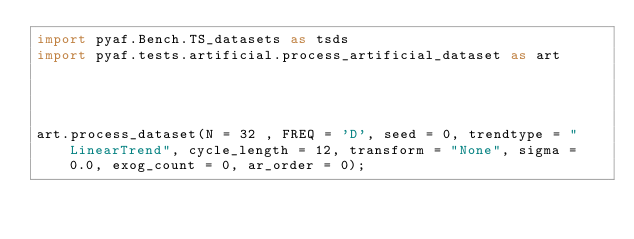<code> <loc_0><loc_0><loc_500><loc_500><_Python_>import pyaf.Bench.TS_datasets as tsds
import pyaf.tests.artificial.process_artificial_dataset as art




art.process_dataset(N = 32 , FREQ = 'D', seed = 0, trendtype = "LinearTrend", cycle_length = 12, transform = "None", sigma = 0.0, exog_count = 0, ar_order = 0);</code> 